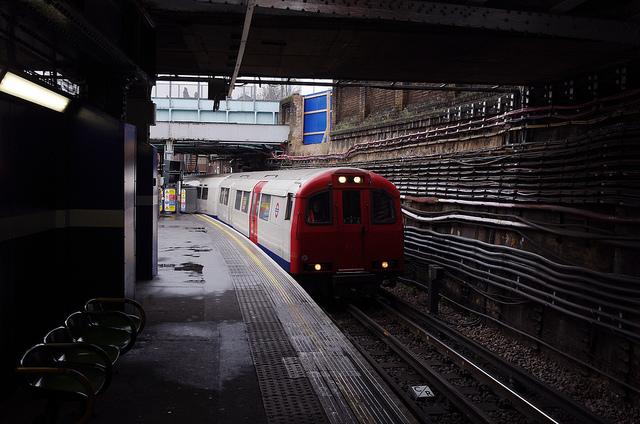Does this train move fast?
Write a very short answer. Yes. What color is the train?
Answer briefly. White. Are there any people on the platform?
Write a very short answer. No. What are on?
Keep it brief. Lights. Is this an electric or diesel train?
Give a very brief answer. Electric. 